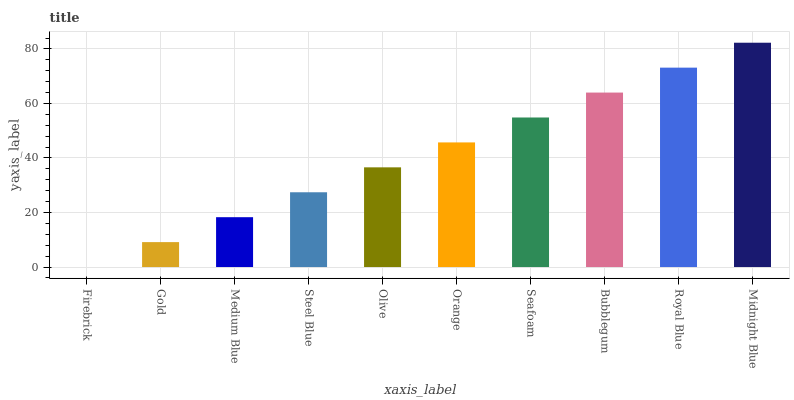Is Firebrick the minimum?
Answer yes or no. Yes. Is Midnight Blue the maximum?
Answer yes or no. Yes. Is Gold the minimum?
Answer yes or no. No. Is Gold the maximum?
Answer yes or no. No. Is Gold greater than Firebrick?
Answer yes or no. Yes. Is Firebrick less than Gold?
Answer yes or no. Yes. Is Firebrick greater than Gold?
Answer yes or no. No. Is Gold less than Firebrick?
Answer yes or no. No. Is Orange the high median?
Answer yes or no. Yes. Is Olive the low median?
Answer yes or no. Yes. Is Olive the high median?
Answer yes or no. No. Is Medium Blue the low median?
Answer yes or no. No. 